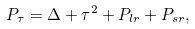Convert formula to latex. <formula><loc_0><loc_0><loc_500><loc_500>P _ { \tau } = \Delta + \tau ^ { 2 } + P _ { l r } + P _ { s r } ,</formula> 